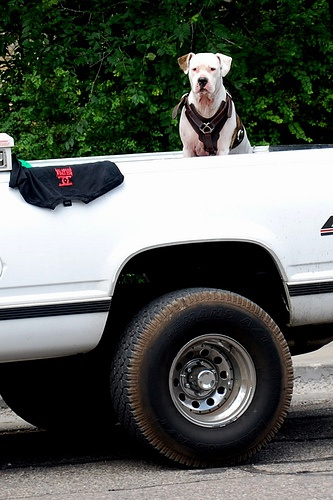Describe the objects in this image and their specific colors. I can see truck in black, white, gray, and darkgray tones and dog in black, lightgray, darkgray, and gray tones in this image. 